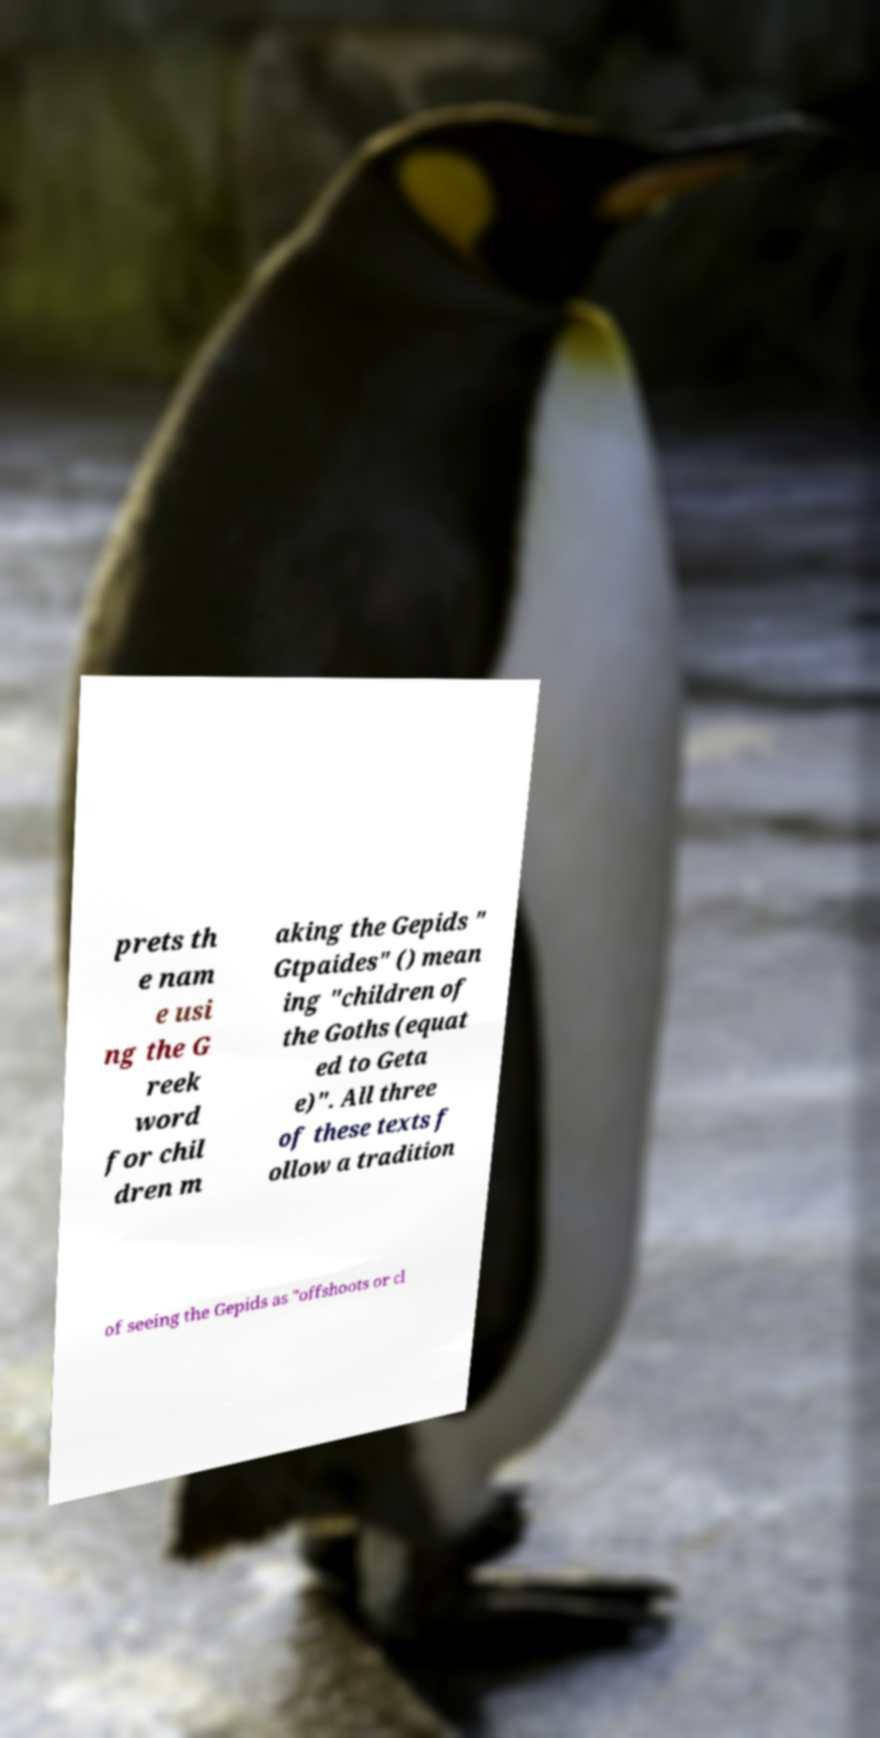Please read and relay the text visible in this image. What does it say? prets th e nam e usi ng the G reek word for chil dren m aking the Gepids " Gtpaides" () mean ing "children of the Goths (equat ed to Geta e)". All three of these texts f ollow a tradition of seeing the Gepids as "offshoots or cl 